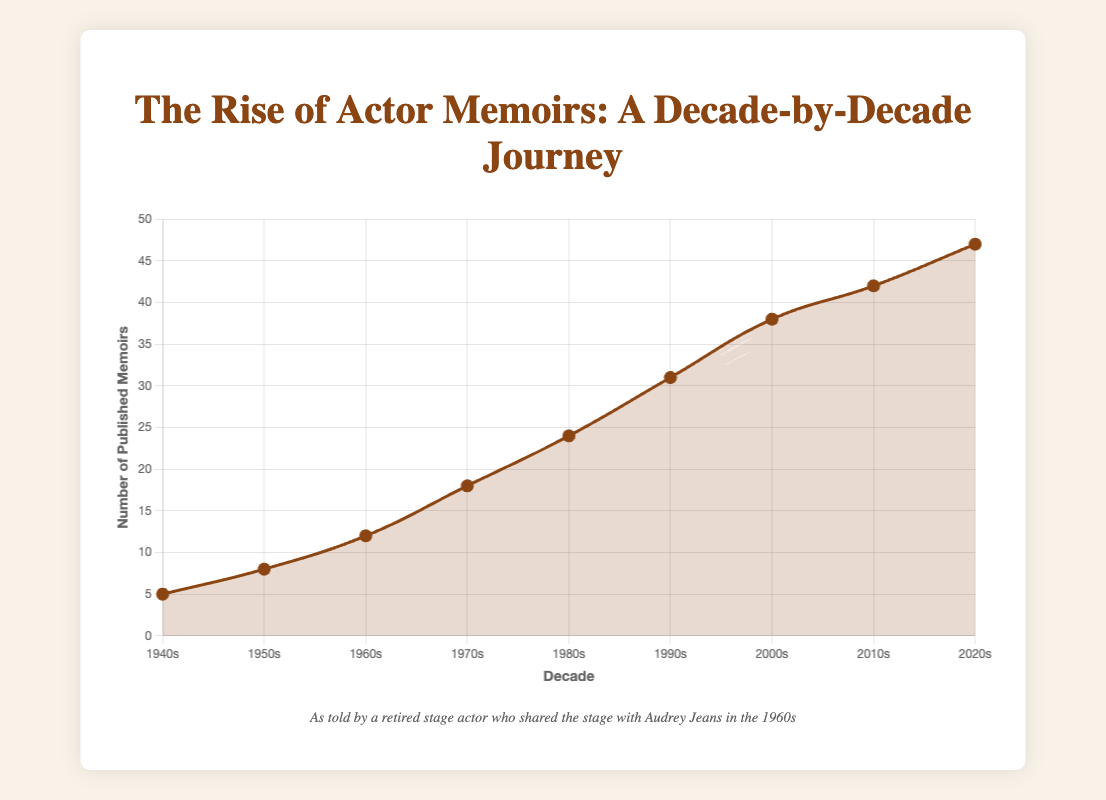What was the decade with the highest number of published memoirs? The figure shows the line plot with data points corresponding to each decade. The highest point is at the decade "2020s" with 47 published memoirs.
Answer: 2020s How many more memoirs were published in the 1980s compared to the 1940s? First, locate the number of published memoirs in both decades. The 1980s had 24, and the 1940s had 5. Compute the difference: 24 - 5 = 19.
Answer: 19 What is the average number of memoirs published per decade from the 1940s to the 2020s? Sum the memoirs published each decade (5 + 8 + 12 + 18 + 24 + 31 + 38 + 42 + 47 = 225) and divide by the number of decades (9). 225 / 9 = 25.
Answer: 25 Which decade saw the largest increase in memoir publications compared to the previous decade? Compare the differences between consecutive decades. The largest increase is from 1990s (31) to 2000s (38), which is an increase of 7.
Answer: 2000s Which decade had fewer memoir publications: the 1950s or the 1970s? Compare the number of memoirs published. The 1950s had 8, and the 1970s had 18. The 1950s had fewer publications.
Answer: 1950s By how much did the number of memoirs published in the 2010s exceed those published in the 1960s? Locate the data points for the 2010s and 1960s. The 2010s had 42, and the 1960s had 12. Calculate the difference: 42 - 12 = 30.
Answer: 30 What is the trend observed in the number of memoirs published over the decades? Observing the line plot, the number of published memoirs consistently rises from the 1940s to the 2020s, showing an increasing trend over time.
Answer: Increasing Between which two consecutive decades was the rate of increase in memoir publications the smallest? Calculate the differences between consecutive decades. The smallest increase is between the 1960s (12) and the 1950s (8), which is 4.
Answer: 1950s to 1960s What visual attributes can you identify for the data points on the plot? The data points are marked with a brown color, filled with brown circles, and connected by a curve. Each data point has a background and hover effect; it stands out more when hovered.
Answer: Brown color, circles, curve 